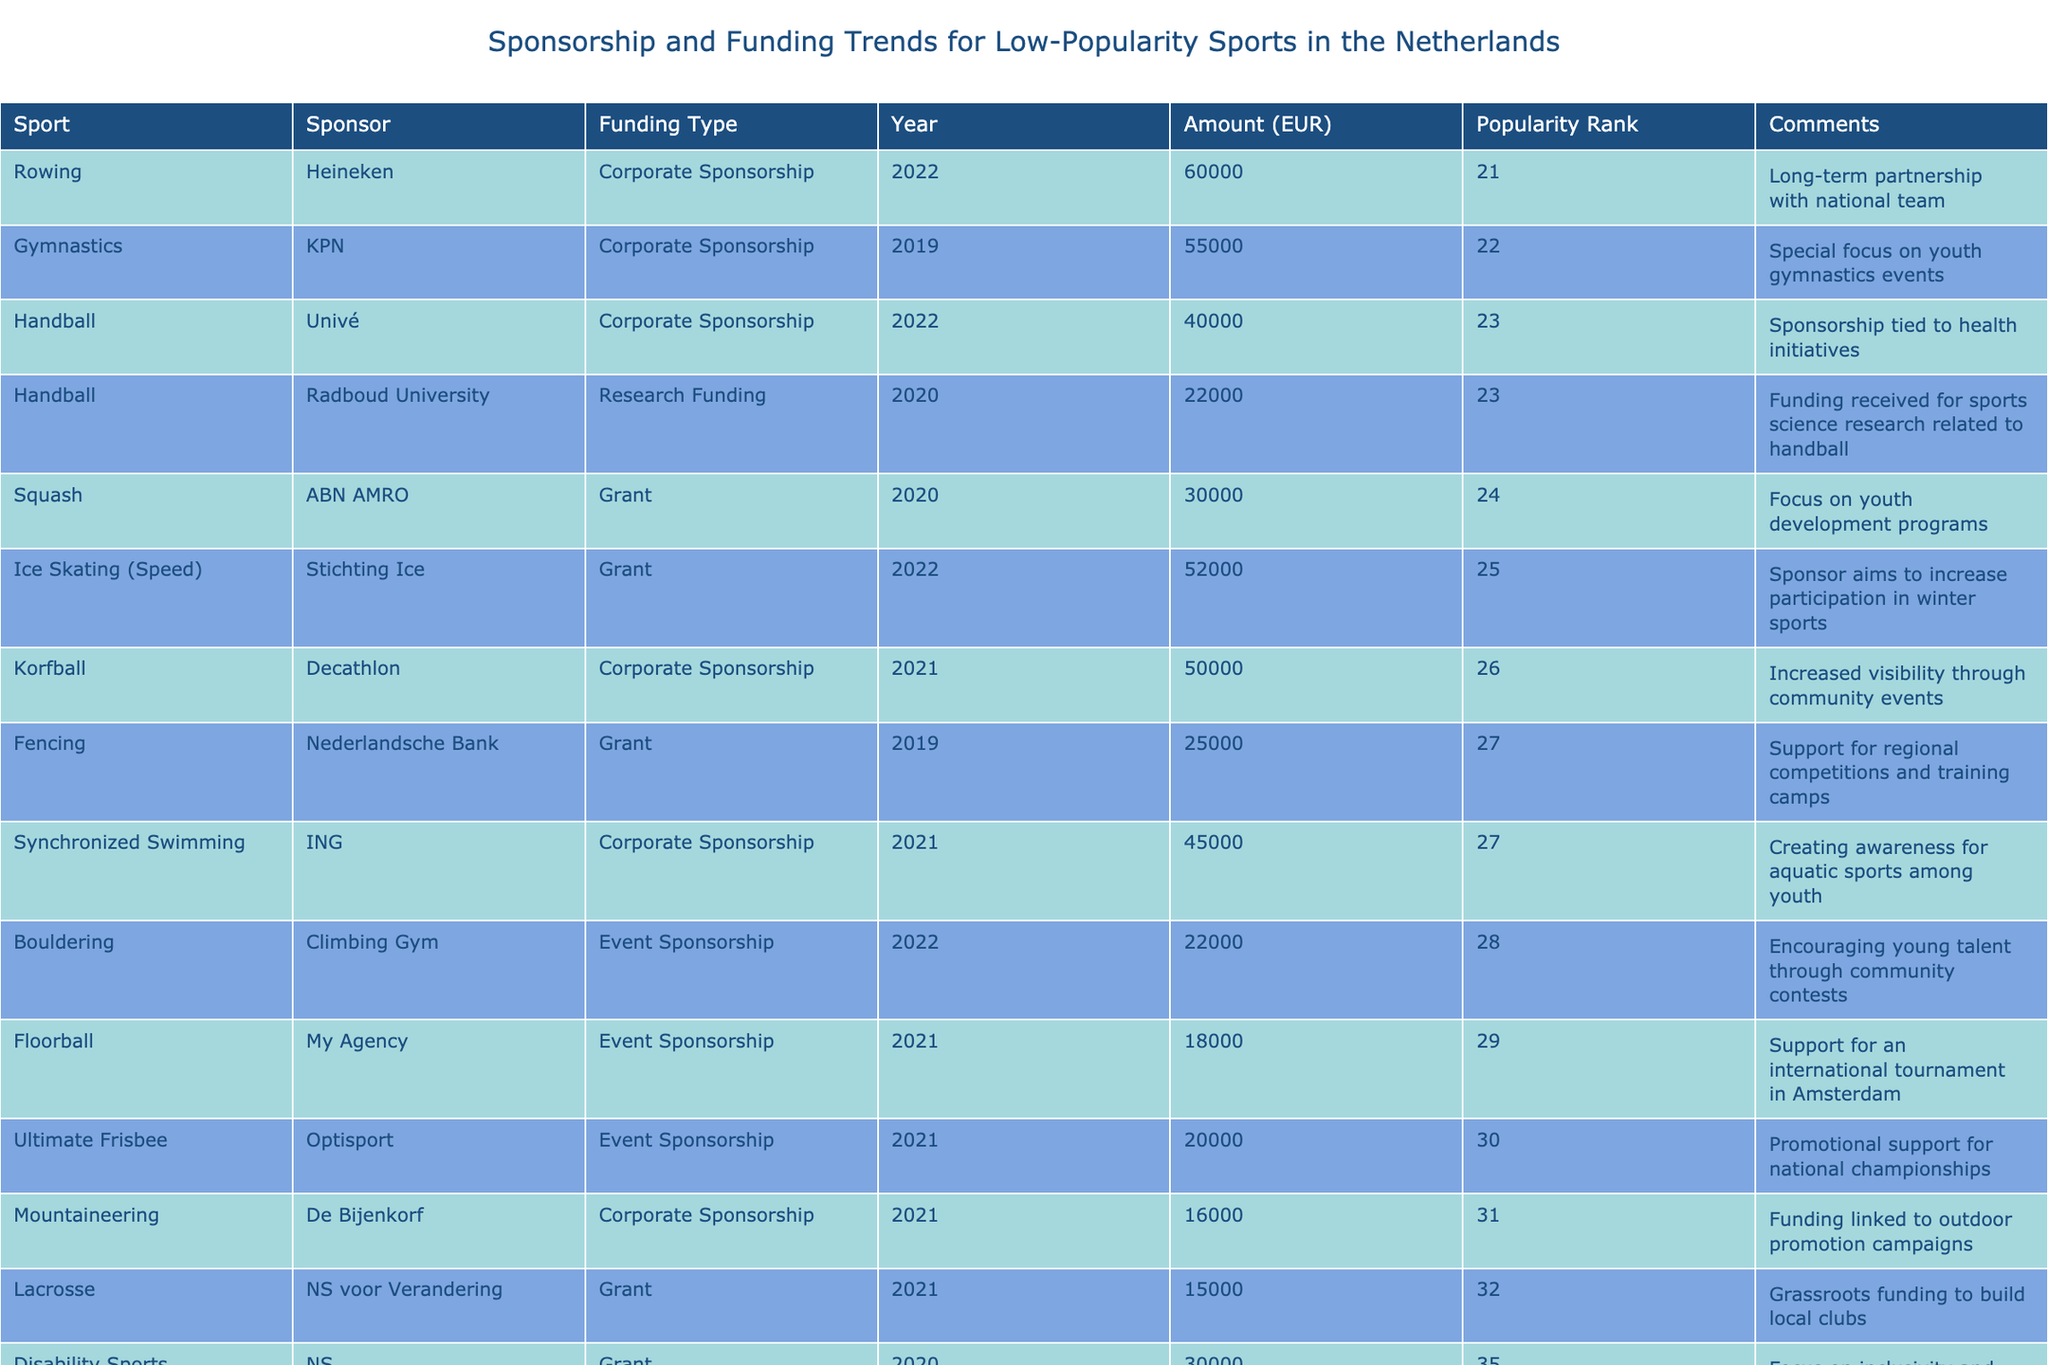What is the total funding amount for Korfball in 2021? The funding amount for Korfball in 2021 is listed as €50,000.
Answer: €50,000 Which sport received funding from both a corporate sponsor and a grant? In the table, Handball received a corporate sponsorship from Univé and a grant from Radboud University, so it fits the criteria.
Answer: Handball Which sport had the lowest popularity rank and what was its sponsorship type? Lacrosse has the lowest popularity rank at 32, with the funding type being a grant from NS voor Verandering.
Answer: Lacrosse, Grant What is the average funding amount for all sports listed in 2021? The total funding amount for 2021 is €304,000 from 8 entries. The average funding amount is €304,000 / 8 = €38,000.
Answer: €38,000 Did any sports receive funding specifically for youth development programs? Yes, Squash received a grant focusing on youth development programs, confirming that there is funding directed towards youth.
Answer: Yes Which sport had the highest funding amount in the table, and who was the sponsor? Rowing received the highest funding amount of €60,000, sponsored by Heineken.
Answer: Rowing, Heineken How much funding did Fencing receive compared to the average funding amount across all sports? Fencing received €25,000. The total funding for all sports listed is €308,000, so the average is €308,000 / 16 = €19,250. Comparing gives us €25,000 which is greater than the average.
Answer: Yes, higher than average What percentage of the total funding amount is attributed to Disability Sports? Disability Sports received €30,000. The total funding is €308,000, so €30,000 is (30,000 / 308,000) * 100% = 9.74%.
Answer: 9.74% How does the corporate sponsorship amount compare between Synchronized Swimming and Ice Skating (Speed)? Synchronized Swimming received €45,000 and Ice Skating (Speed) received €52,000. Thus, Ice Skating (Speed) received more corporate sponsorship by €7,000.
Answer: Ice Skating (Speed) received €7,000 more 